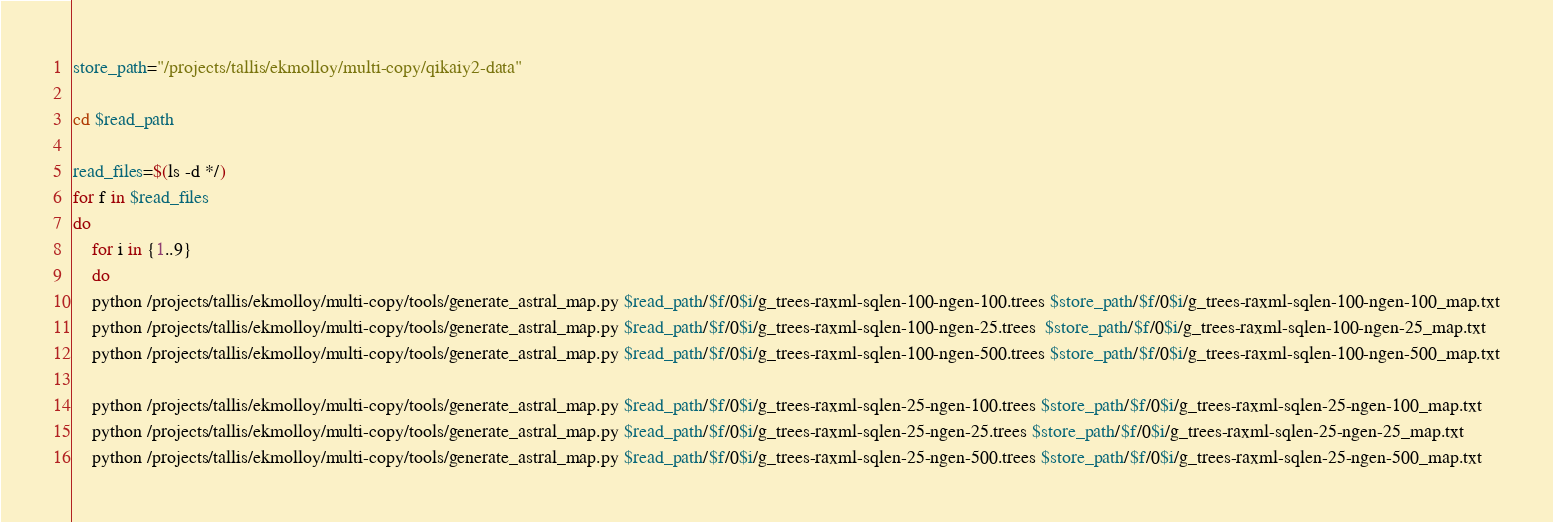Convert code to text. <code><loc_0><loc_0><loc_500><loc_500><_Bash_>store_path="/projects/tallis/ekmolloy/multi-copy/qikaiy2-data"

cd $read_path

read_files=$(ls -d */)
for f in $read_files
do
	for i in {1..9}
	do
	python /projects/tallis/ekmolloy/multi-copy/tools/generate_astral_map.py $read_path/$f/0$i/g_trees-raxml-sqlen-100-ngen-100.trees $store_path/$f/0$i/g_trees-raxml-sqlen-100-ngen-100_map.txt
	python /projects/tallis/ekmolloy/multi-copy/tools/generate_astral_map.py $read_path/$f/0$i/g_trees-raxml-sqlen-100-ngen-25.trees  $store_path/$f/0$i/g_trees-raxml-sqlen-100-ngen-25_map.txt
	python /projects/tallis/ekmolloy/multi-copy/tools/generate_astral_map.py $read_path/$f/0$i/g_trees-raxml-sqlen-100-ngen-500.trees $store_path/$f/0$i/g_trees-raxml-sqlen-100-ngen-500_map.txt

	python /projects/tallis/ekmolloy/multi-copy/tools/generate_astral_map.py $read_path/$f/0$i/g_trees-raxml-sqlen-25-ngen-100.trees $store_path/$f/0$i/g_trees-raxml-sqlen-25-ngen-100_map.txt
	python /projects/tallis/ekmolloy/multi-copy/tools/generate_astral_map.py $read_path/$f/0$i/g_trees-raxml-sqlen-25-ngen-25.trees $store_path/$f/0$i/g_trees-raxml-sqlen-25-ngen-25_map.txt
	python /projects/tallis/ekmolloy/multi-copy/tools/generate_astral_map.py $read_path/$f/0$i/g_trees-raxml-sqlen-25-ngen-500.trees $store_path/$f/0$i/g_trees-raxml-sqlen-25-ngen-500_map.txt
</code> 